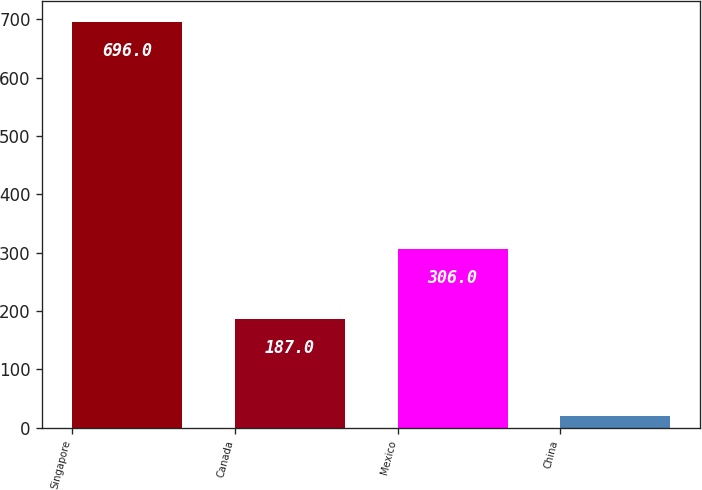<chart> <loc_0><loc_0><loc_500><loc_500><bar_chart><fcel>Singapore<fcel>Canada<fcel>Mexico<fcel>China<nl><fcel>696<fcel>187<fcel>306<fcel>20<nl></chart> 